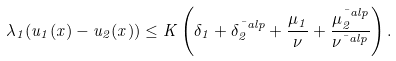<formula> <loc_0><loc_0><loc_500><loc_500>\lambda _ { 1 } ( u _ { 1 } ( x ) - u _ { 2 } ( x ) ) \leq K \left ( \delta _ { 1 } + \delta _ { 2 } ^ { \bar { \ } a l p } + \frac { \mu _ { 1 } } { \nu } + \frac { \mu _ { 2 } ^ { \bar { \ } a l p } } { \nu ^ { \bar { \ } a l p } } \right ) .</formula> 